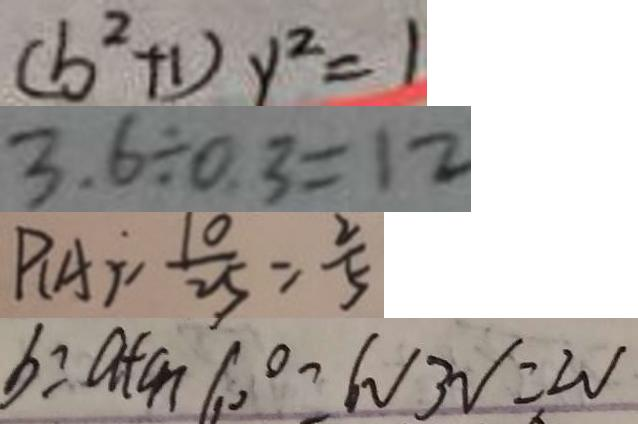<formula> <loc_0><loc_0><loc_500><loc_500>( b ^ { 2 } + 1 ) y ^ { 2 } = 1 
 3 . 6 \div 0 . 3 = 1 2 
 P _ { ( A ) } = \frac { 1 0 } { 2 5 } = \frac { 2 } { 5 } 
 b = a + c n 6 0 ^ { \circ } - 6 V _ { 3 V } = 2 V</formula> 